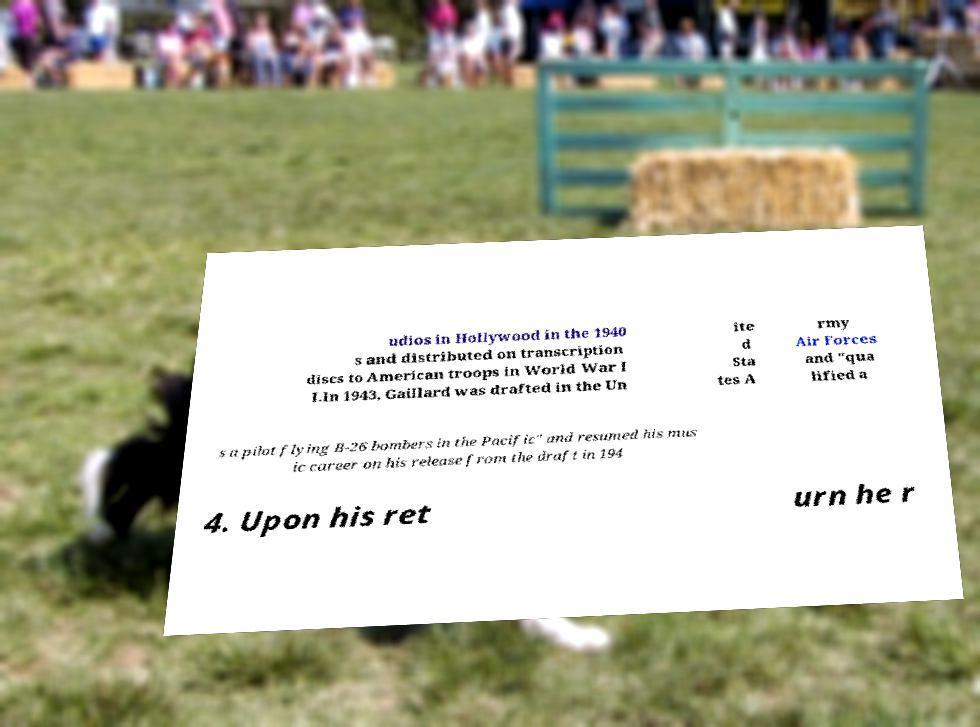Please read and relay the text visible in this image. What does it say? udios in Hollywood in the 1940 s and distributed on transcription discs to American troops in World War I I.In 1943, Gaillard was drafted in the Un ite d Sta tes A rmy Air Forces and "qua lified a s a pilot flying B-26 bombers in the Pacific" and resumed his mus ic career on his release from the draft in 194 4. Upon his ret urn he r 